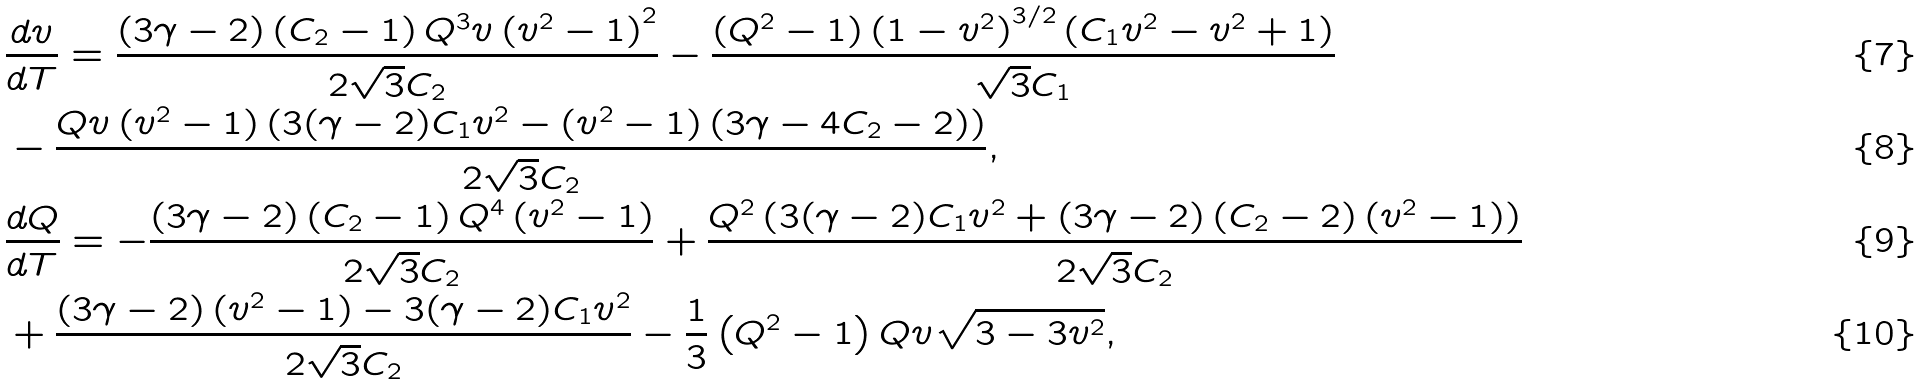Convert formula to latex. <formula><loc_0><loc_0><loc_500><loc_500>& \frac { d v } { d T } = \frac { ( 3 \gamma - 2 ) \left ( C _ { 2 } - 1 \right ) Q ^ { 3 } v \left ( v ^ { 2 } - 1 \right ) ^ { 2 } } { 2 \sqrt { 3 } C _ { 2 } } - \frac { \left ( Q ^ { 2 } - 1 \right ) \left ( 1 - v ^ { 2 } \right ) ^ { 3 / 2 } \left ( C _ { 1 } v ^ { 2 } - v ^ { 2 } + 1 \right ) } { \sqrt { 3 } C _ { 1 } } \\ & - \frac { Q v \left ( v ^ { 2 } - 1 \right ) \left ( 3 ( \gamma - 2 ) C _ { 1 } v ^ { 2 } - \left ( v ^ { 2 } - 1 \right ) \left ( 3 \gamma - 4 C _ { 2 } - 2 \right ) \right ) } { 2 \sqrt { 3 } C _ { 2 } } , \\ & \frac { d Q } { d T } = - \frac { ( 3 \gamma - 2 ) \left ( C _ { 2 } - 1 \right ) Q ^ { 4 } \left ( v ^ { 2 } - 1 \right ) } { 2 \sqrt { 3 } C _ { 2 } } + \frac { Q ^ { 2 } \left ( 3 ( \gamma - 2 ) C _ { 1 } v ^ { 2 } + ( 3 \gamma - 2 ) \left ( C _ { 2 } - 2 \right ) \left ( v ^ { 2 } - 1 \right ) \right ) } { 2 \sqrt { 3 } C _ { 2 } } \\ & + \frac { ( 3 \gamma - 2 ) \left ( v ^ { 2 } - 1 \right ) - 3 ( \gamma - 2 ) C _ { 1 } v ^ { 2 } } { 2 \sqrt { 3 } C _ { 2 } } - \frac { 1 } { 3 } \left ( Q ^ { 2 } - 1 \right ) Q v \sqrt { 3 - 3 v ^ { 2 } } ,</formula> 